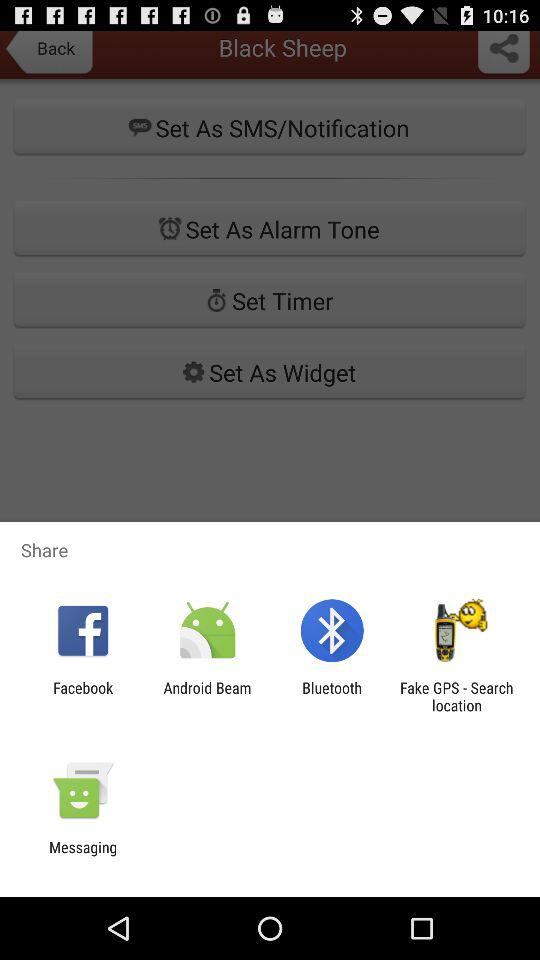Through what applications can we share? The applications through which you can share are "Facebook", "Android Beam", "Bluetooth", "Fake GPS - Search location" and "Messaging". 